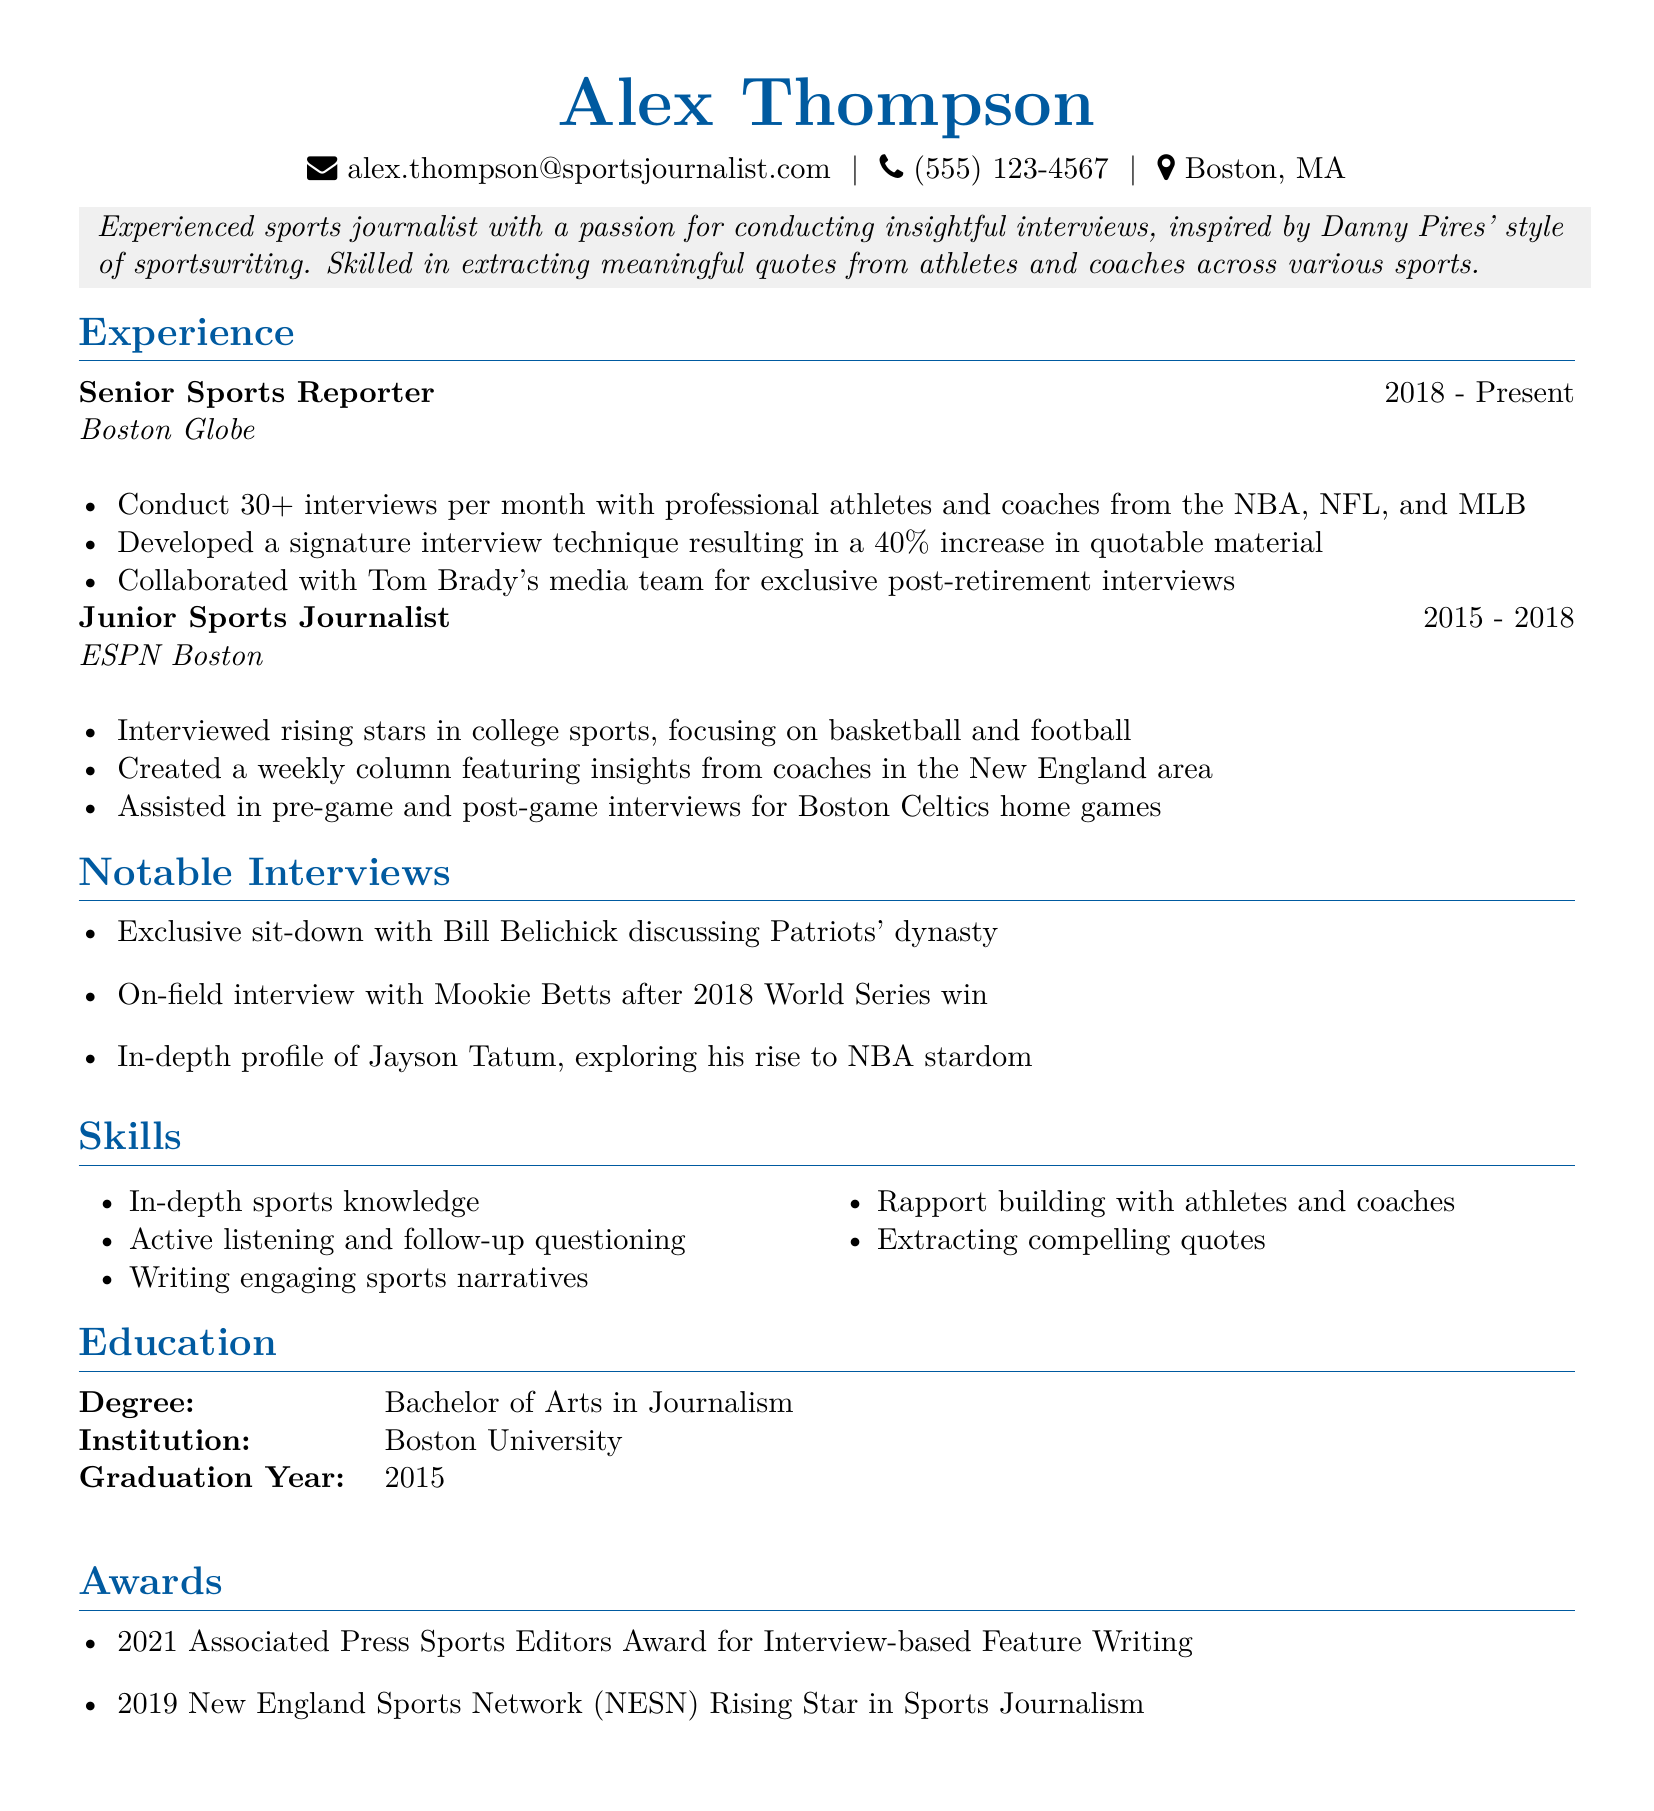What is the full name of the individual? The full name of the individual is provided in the personal info section of the document.
Answer: Alex Thompson What is the email address listed in the resume? The email address can be found in the personal information section.
Answer: alex.thompson@sportsjournalist.com What position does Alex Thompson currently hold? The current job title can be found under the work experience section.
Answer: Senior Sports Reporter How many interviews does Alex conduct per month at the Boston Globe? The number of interviews can be found in the responsibilities of the current job description.
Answer: 30+ How long did Alex work at ESPN Boston? The duration of employment is indicated under the work experience section.
Answer: 2015 - 2018 Which notable interview involved Bill Belichick? This interview can be found in the notable interviews section of the resume.
Answer: Exclusive sit-down with Bill Belichick discussing Patriots' dynasty What award did Alex receive in 2021? The specific award is mentioned in the awards section.
Answer: Associated Press Sports Editors Award for Interview-based Feature Writing What is the degree that Alex earned? The degree is listed under the education section of the resume.
Answer: Bachelor of Arts in Journalism What skill is highlighted for rapport building? This skill can be found in the skills section of the document.
Answer: Rapport building with athletes and coaches 